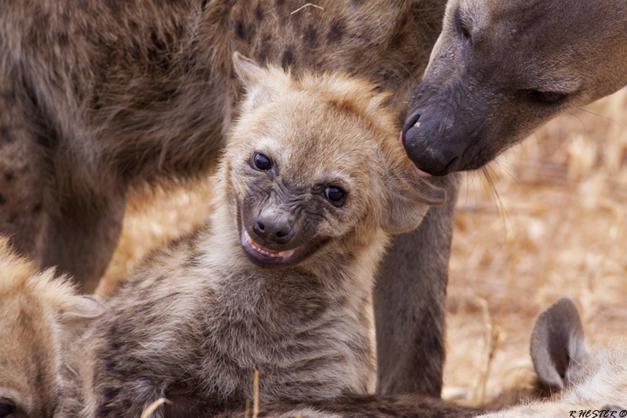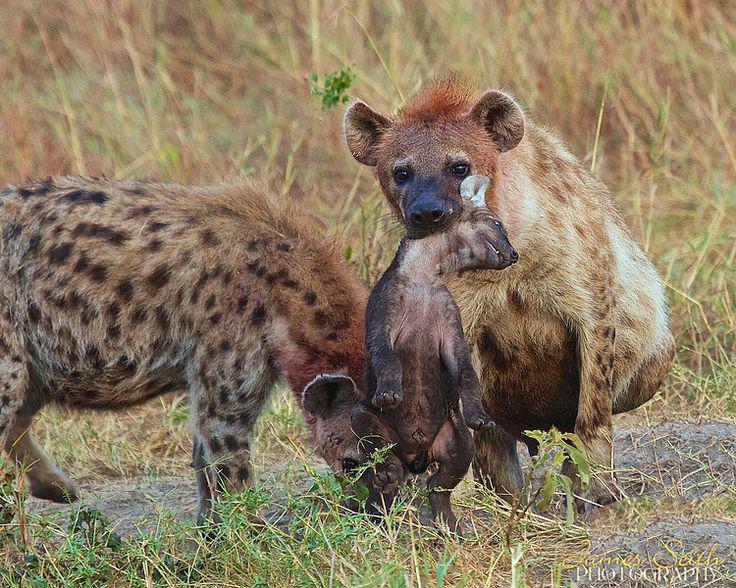The first image is the image on the left, the second image is the image on the right. For the images shown, is this caption "The animals in both pictures are facing left." true? Answer yes or no. No. The first image is the image on the left, the second image is the image on the right. Analyze the images presented: Is the assertion "Each image contains exactly one hyena, and each hyena pictured has its head on the left of the image." valid? Answer yes or no. No. 